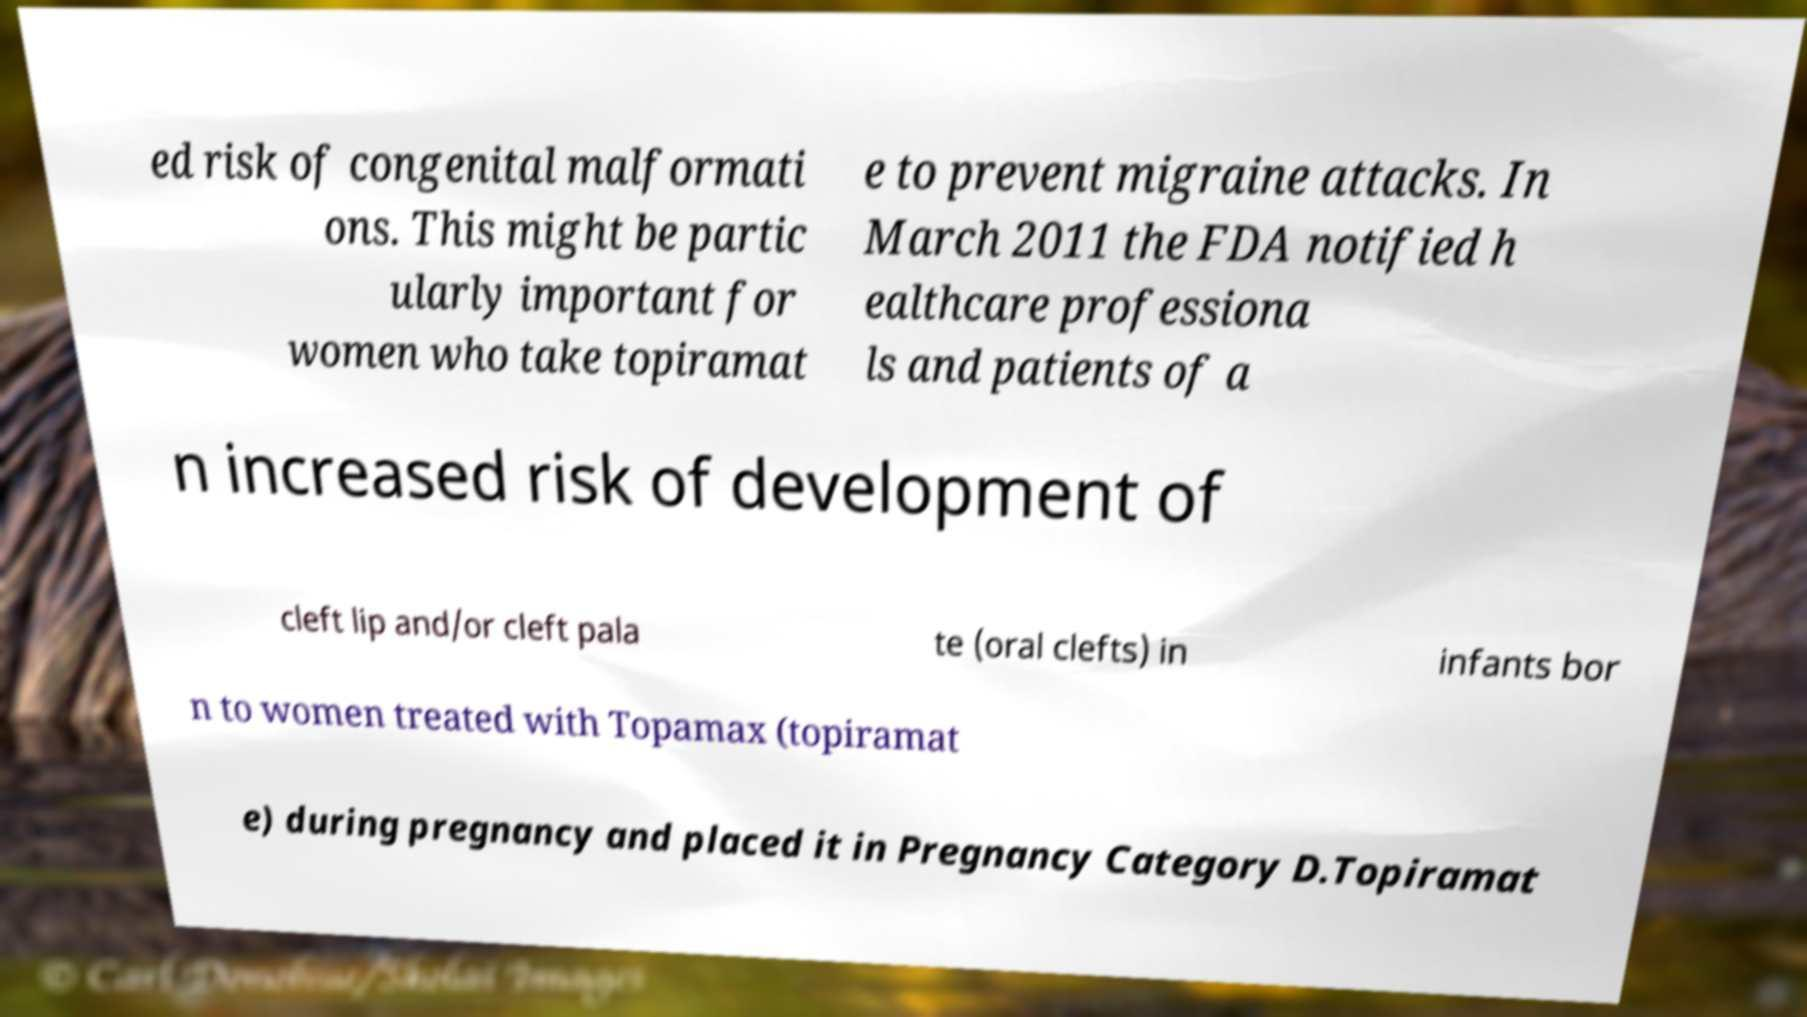Please read and relay the text visible in this image. What does it say? ed risk of congenital malformati ons. This might be partic ularly important for women who take topiramat e to prevent migraine attacks. In March 2011 the FDA notified h ealthcare professiona ls and patients of a n increased risk of development of cleft lip and/or cleft pala te (oral clefts) in infants bor n to women treated with Topamax (topiramat e) during pregnancy and placed it in Pregnancy Category D.Topiramat 